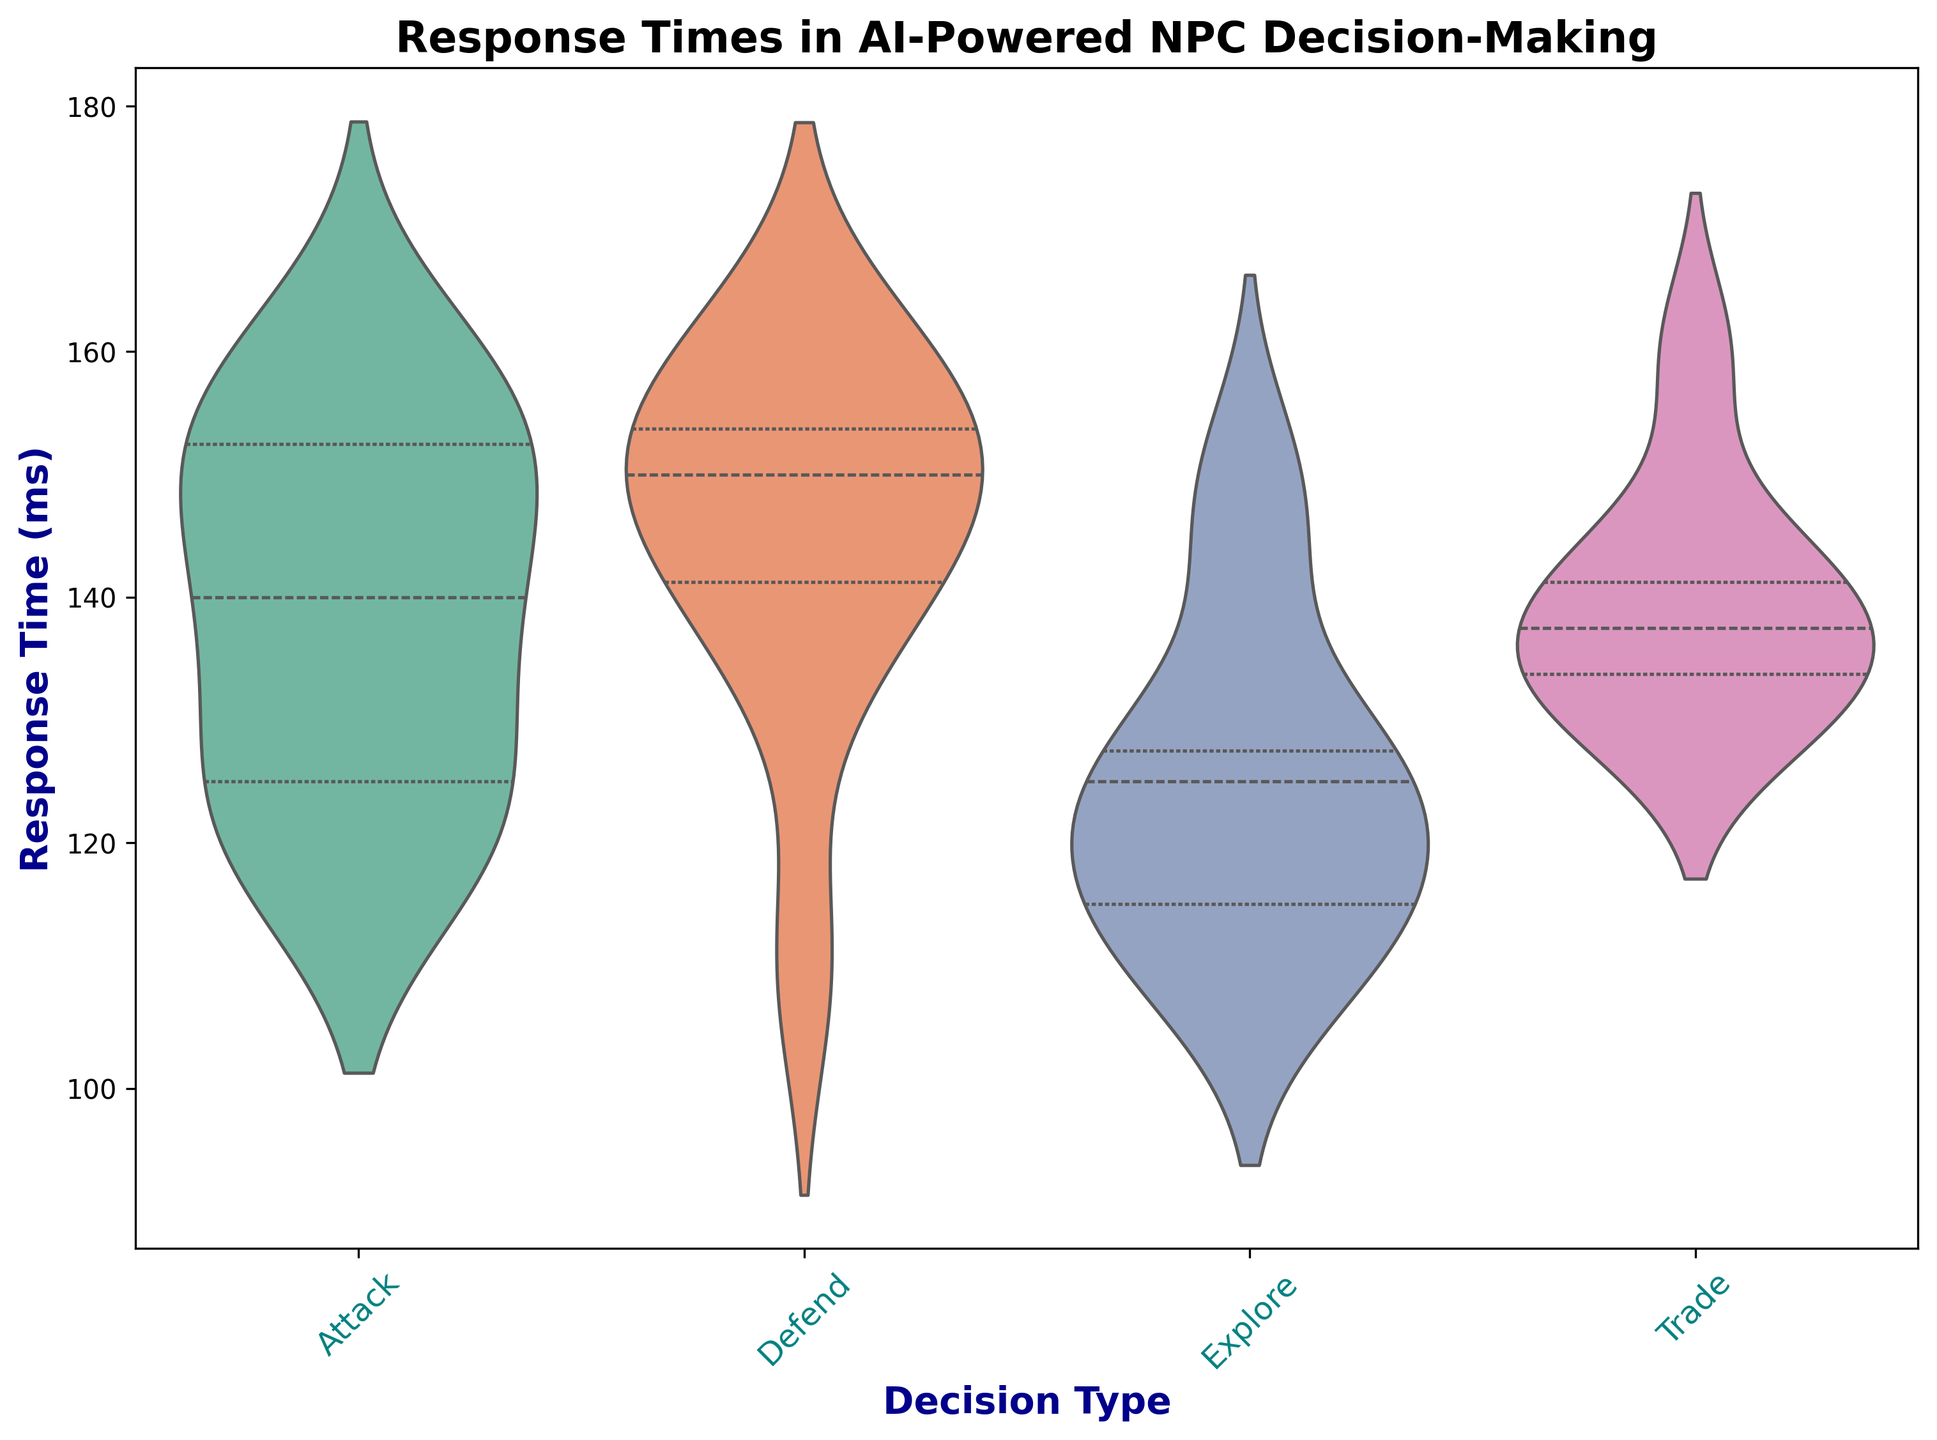Which Decision Type has the lowest median Response Time? By observing the quartile lines within the violin plots, we can see which Decision Type has the lowest central line. The Explore type has the lowest median.
Answer: Explore What's the range of Response Times for the Attack Decision Type? The range is calculated by subtracting the minimum Response Time from the maximum Response Time within the Attack category. Visually, it spans from approximately 120ms to 160ms.
Answer: 40ms Comparing the median Response Time, which is higher: Trade or Defend? The median line, represented by the central tick within each violin plot, shows the Defend category median is higher than the Trade category median.
Answer: Defend What is the most variable Decision Type in terms of Response Time? The variability can be seen by the width and spread of the violin plots. A wider and more spread out plot indicates higher variability. The Defend plot appears to show the largest spread.
Answer: Defend What is the interquartile range (IQR) for the Explore Decision Type? The IQR is the range between the first quartile (Q1) and the third quartile (Q3). The Q3 and Q1 lines within the Explore plot span from approximately 115ms to 145ms. Therefore, IQR = 145ms - 115ms.
Answer: 30ms Between which Decision Types do the median Response Times appear closest? By examining the central tick marks in each plot, the Attack and Trade categories have closely aligned medians.
Answer: Attack and Trade Which Decision Type has the smallest Interquartile Range (IQR)? The IQR is smallest where the Q1 to Q3 spread is narrowest. By observing, the Attack category has the narrowest span from Q1 to Q3.
Answer: Attack Which Decision Type's Response Times extend above 160ms? The only Decision Type whose violin extends above 160ms is the Defend category.
Answer: Defend What is the difference between the maximum Response Times for Attack and Explore Decision Types? The maximum Response Time for Attack is around 160ms and for Explore is around 150ms. The difference can be calculated as 160ms - 150ms.
Answer: 10ms Is there any Decision Type that does not reach below 120ms in its Response Time distribution? Observing the lowest points in the distributions, all Decision Types go below 120ms except the Trade category.
Answer: Trade 